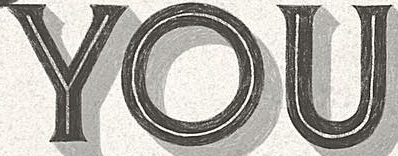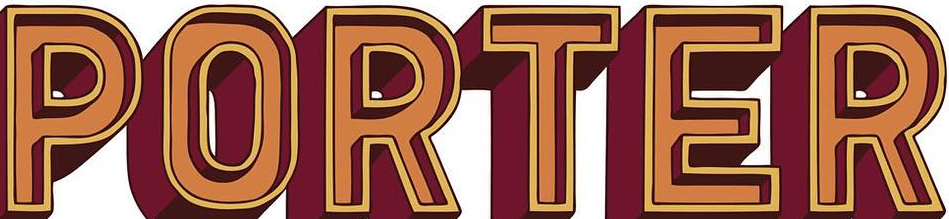What words are shown in these images in order, separated by a semicolon? YOU; PORTER 